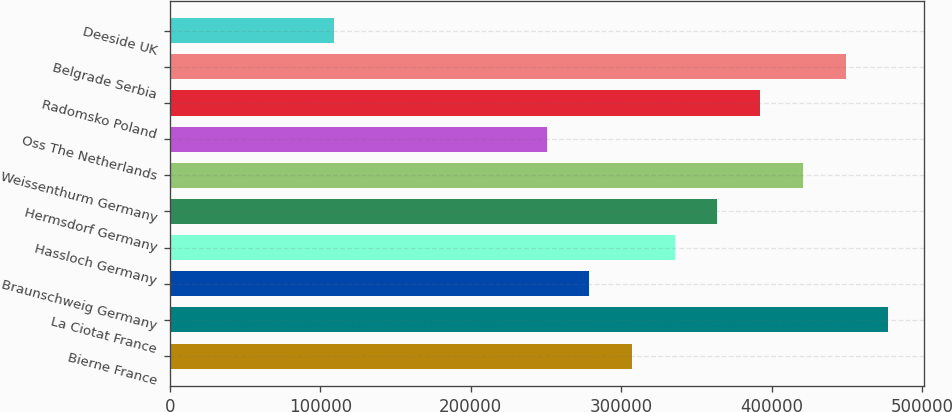Convert chart to OTSL. <chart><loc_0><loc_0><loc_500><loc_500><bar_chart><fcel>Bierne France<fcel>La Ciotat France<fcel>Braunschweig Germany<fcel>Hassloch Germany<fcel>Hermsdorf Germany<fcel>Weissenthurm Germany<fcel>Oss The Netherlands<fcel>Radomsko Poland<fcel>Belgrade Serbia<fcel>Deeside UK<nl><fcel>307200<fcel>477600<fcel>278800<fcel>335600<fcel>364000<fcel>420800<fcel>250400<fcel>392400<fcel>449200<fcel>109000<nl></chart> 